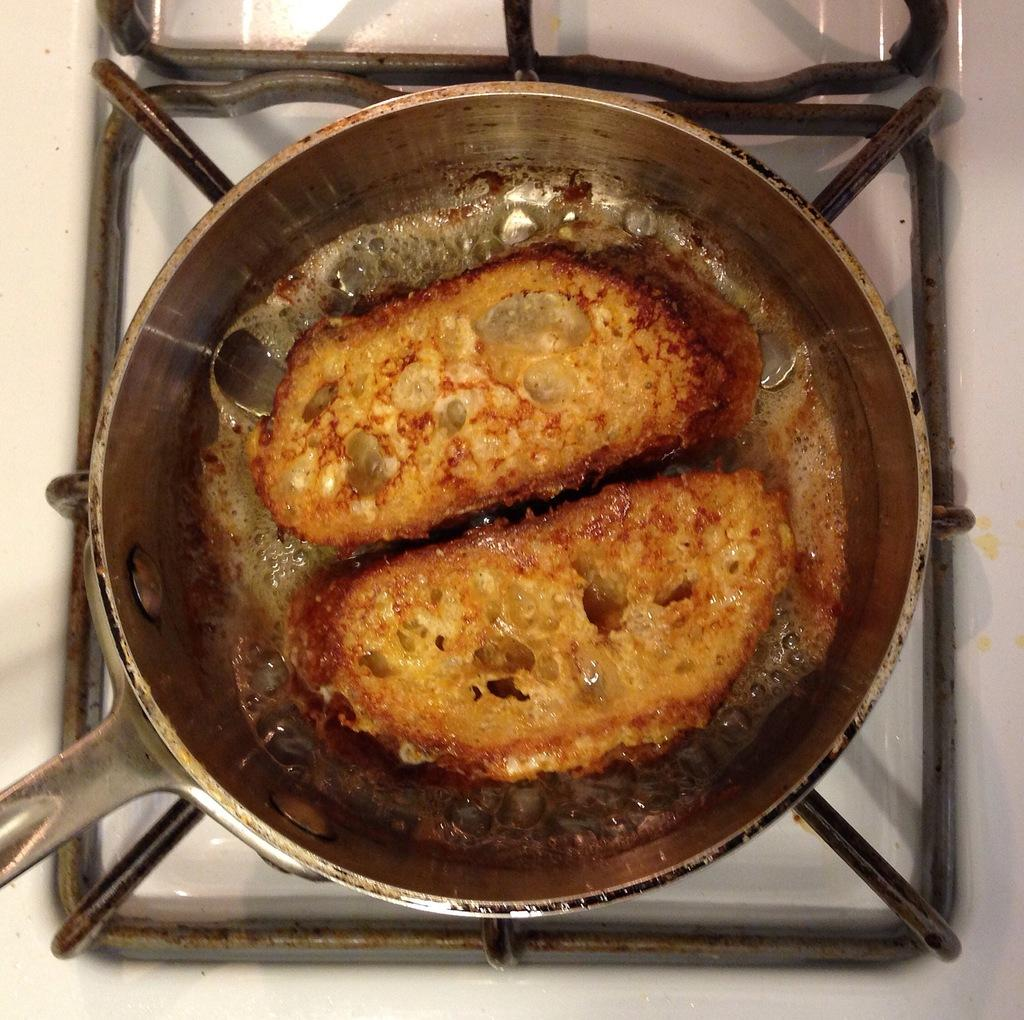What is the main subject of the image? There is a food item in the image. How is the food item being prepared? The food item is placed on a pan. Where is the pan located? The pan is on a stove. What type of truck can be seen delivering a birthday cake in the image? There is no truck or birthday cake present in the image; it only features a food item on a pan on a stove. 